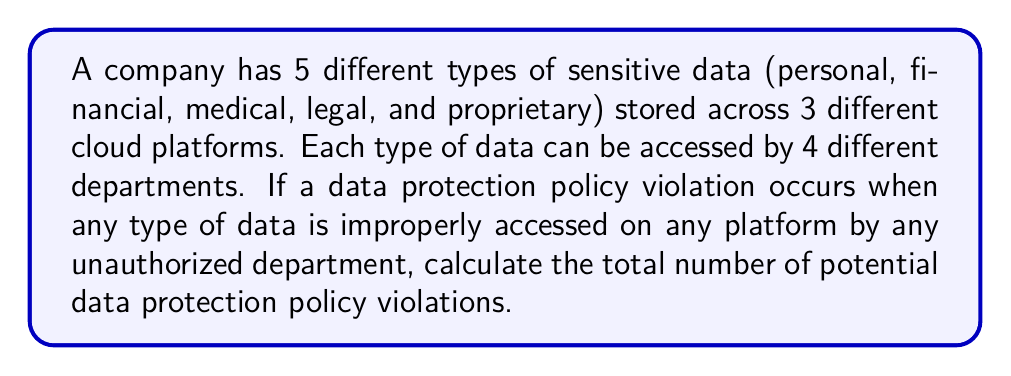Teach me how to tackle this problem. Let's approach this step-by-step using the multiplication principle of combinatorics:

1) We need to consider three independent choices:
   - Type of sensitive data: 5 choices
   - Cloud platform: 3 choices
   - Unauthorized department: 3 choices (since one of the 4 departments is authorized)

2) For each type of data, we can have a violation on any of the 3 platforms, by any of the 3 unauthorized departments.

3) Using the multiplication principle, the total number of potential violations is:

   $$ \text{Total Violations} = \text{Data Types} \times \text{Platforms} \times \text{Unauthorized Departments} $$
   
   $$ \text{Total Violations} = 5 \times 3 \times 3 = 45 $$

4) This calculation assumes that each combination represents a unique potential violation.
Answer: 45 